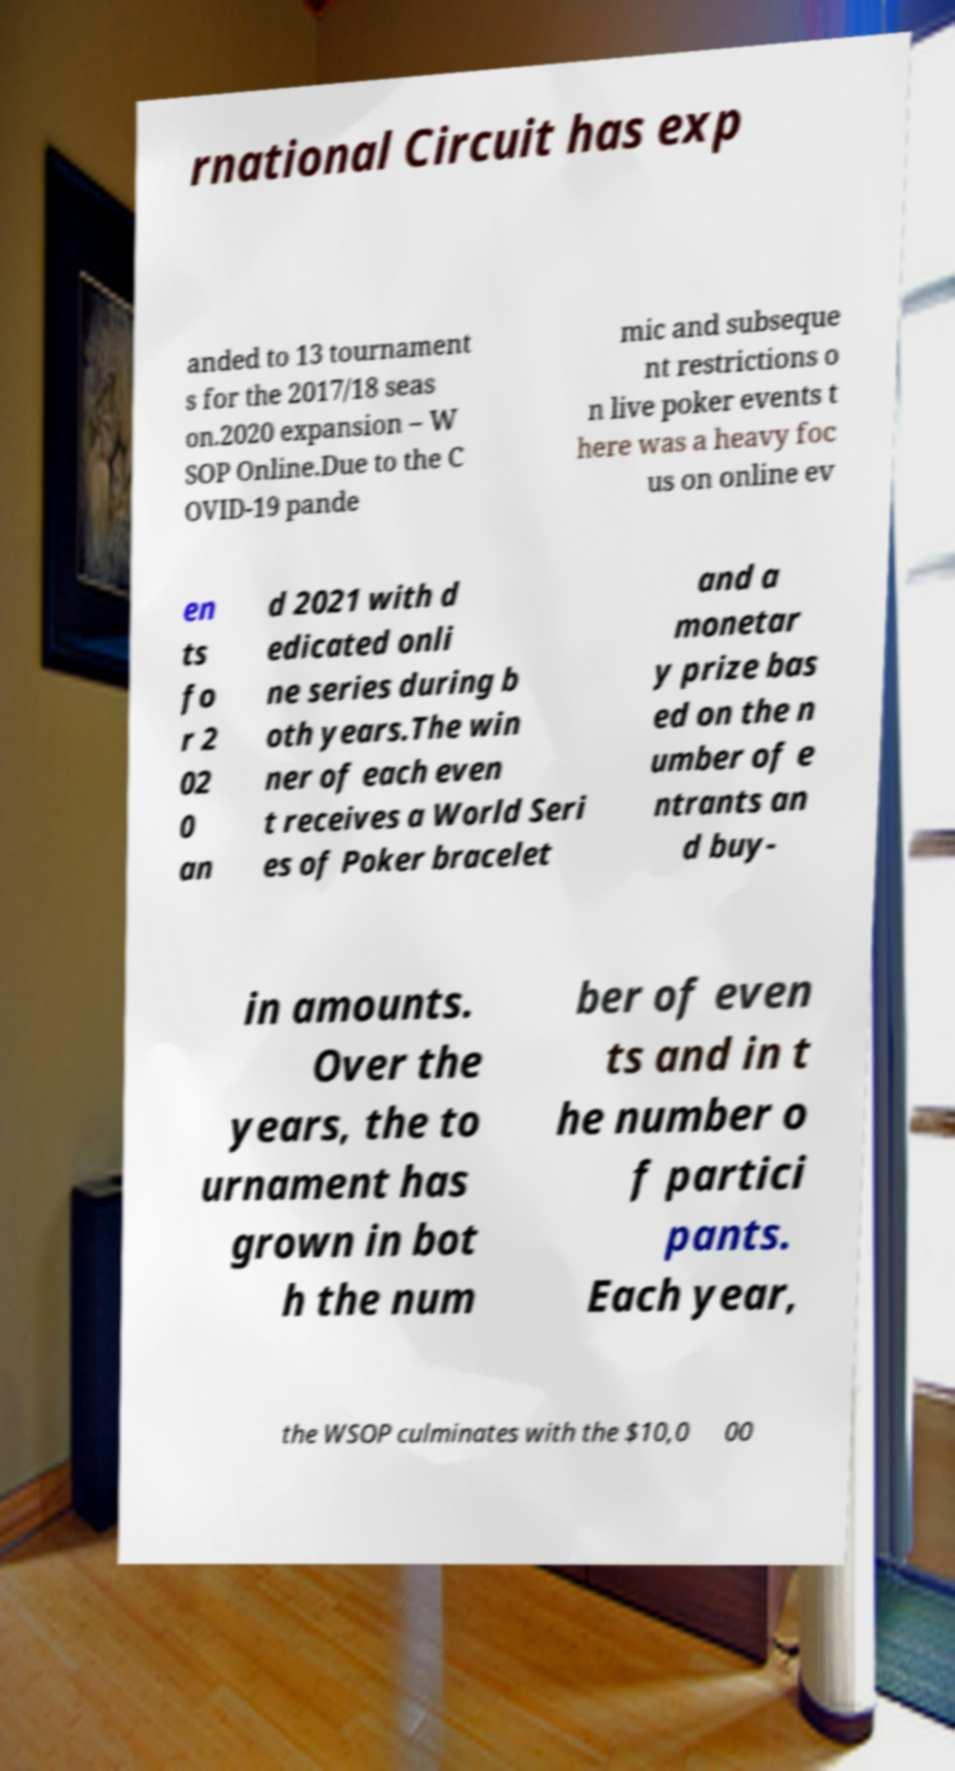Please identify and transcribe the text found in this image. rnational Circuit has exp anded to 13 tournament s for the 2017/18 seas on.2020 expansion – W SOP Online.Due to the C OVID-19 pande mic and subseque nt restrictions o n live poker events t here was a heavy foc us on online ev en ts fo r 2 02 0 an d 2021 with d edicated onli ne series during b oth years.The win ner of each even t receives a World Seri es of Poker bracelet and a monetar y prize bas ed on the n umber of e ntrants an d buy- in amounts. Over the years, the to urnament has grown in bot h the num ber of even ts and in t he number o f partici pants. Each year, the WSOP culminates with the $10,0 00 